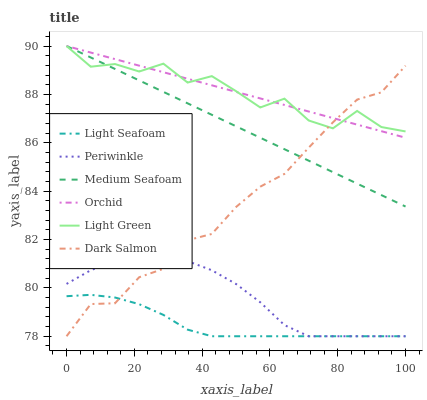Does Light Seafoam have the minimum area under the curve?
Answer yes or no. Yes. Does Orchid have the maximum area under the curve?
Answer yes or no. Yes. Does Periwinkle have the minimum area under the curve?
Answer yes or no. No. Does Periwinkle have the maximum area under the curve?
Answer yes or no. No. Is Medium Seafoam the smoothest?
Answer yes or no. Yes. Is Light Green the roughest?
Answer yes or no. Yes. Is Periwinkle the smoothest?
Answer yes or no. No. Is Periwinkle the roughest?
Answer yes or no. No. Does Dark Salmon have the lowest value?
Answer yes or no. Yes. Does Light Green have the lowest value?
Answer yes or no. No. Does Orchid have the highest value?
Answer yes or no. Yes. Does Periwinkle have the highest value?
Answer yes or no. No. Is Periwinkle less than Medium Seafoam?
Answer yes or no. Yes. Is Orchid greater than Periwinkle?
Answer yes or no. Yes. Does Medium Seafoam intersect Light Green?
Answer yes or no. Yes. Is Medium Seafoam less than Light Green?
Answer yes or no. No. Is Medium Seafoam greater than Light Green?
Answer yes or no. No. Does Periwinkle intersect Medium Seafoam?
Answer yes or no. No. 